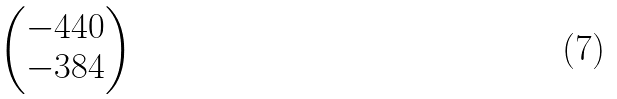<formula> <loc_0><loc_0><loc_500><loc_500>\begin{pmatrix} - 4 4 0 \\ - 3 8 4 \end{pmatrix}</formula> 